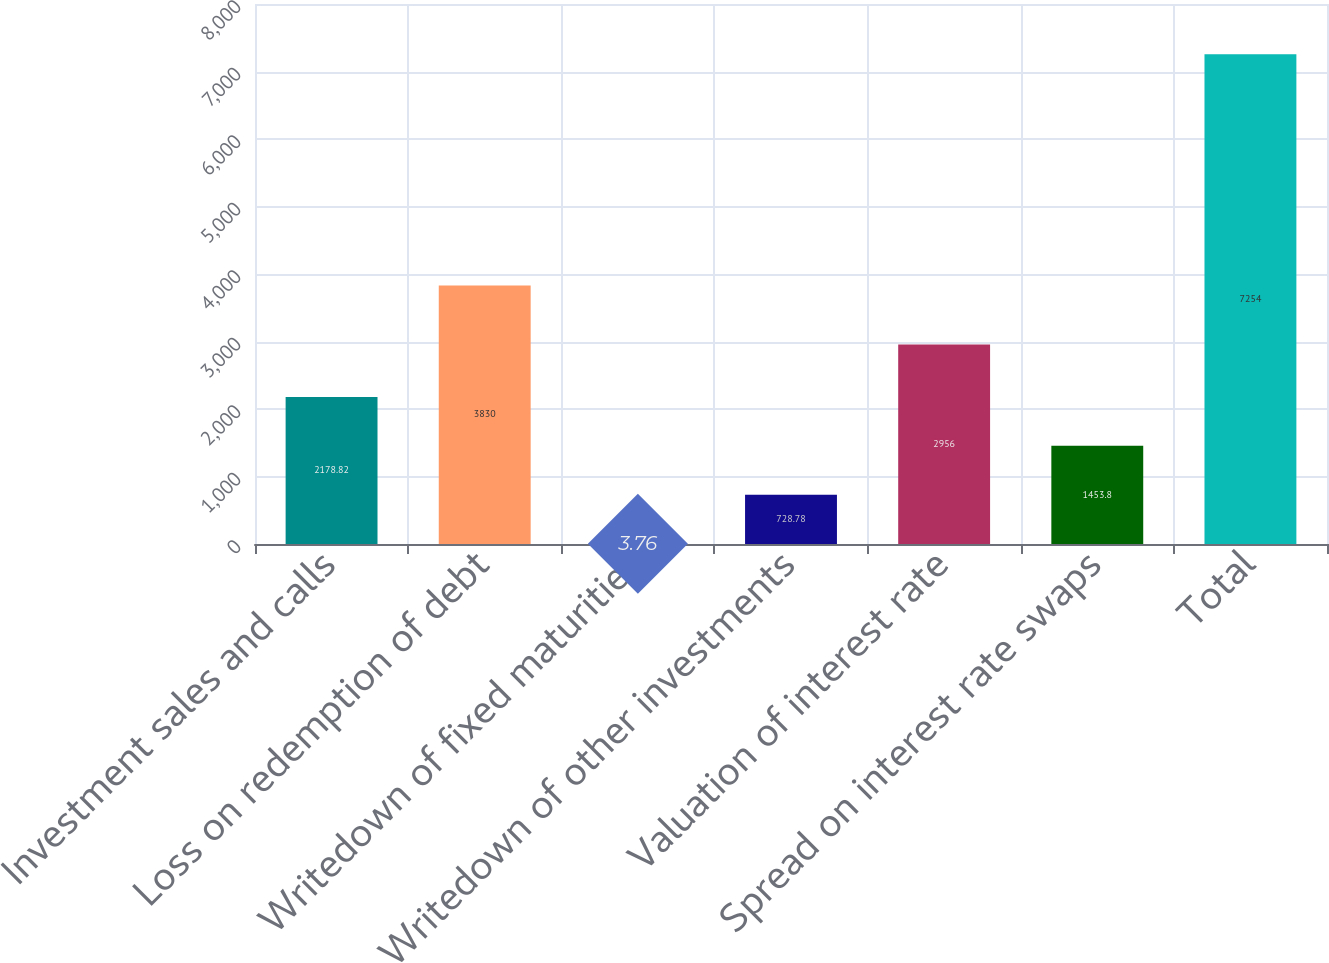<chart> <loc_0><loc_0><loc_500><loc_500><bar_chart><fcel>Investment sales and calls<fcel>Loss on redemption of debt<fcel>Writedown of fixed maturities<fcel>Writedown of other investments<fcel>Valuation of interest rate<fcel>Spread on interest rate swaps<fcel>Total<nl><fcel>2178.82<fcel>3830<fcel>3.76<fcel>728.78<fcel>2956<fcel>1453.8<fcel>7254<nl></chart> 